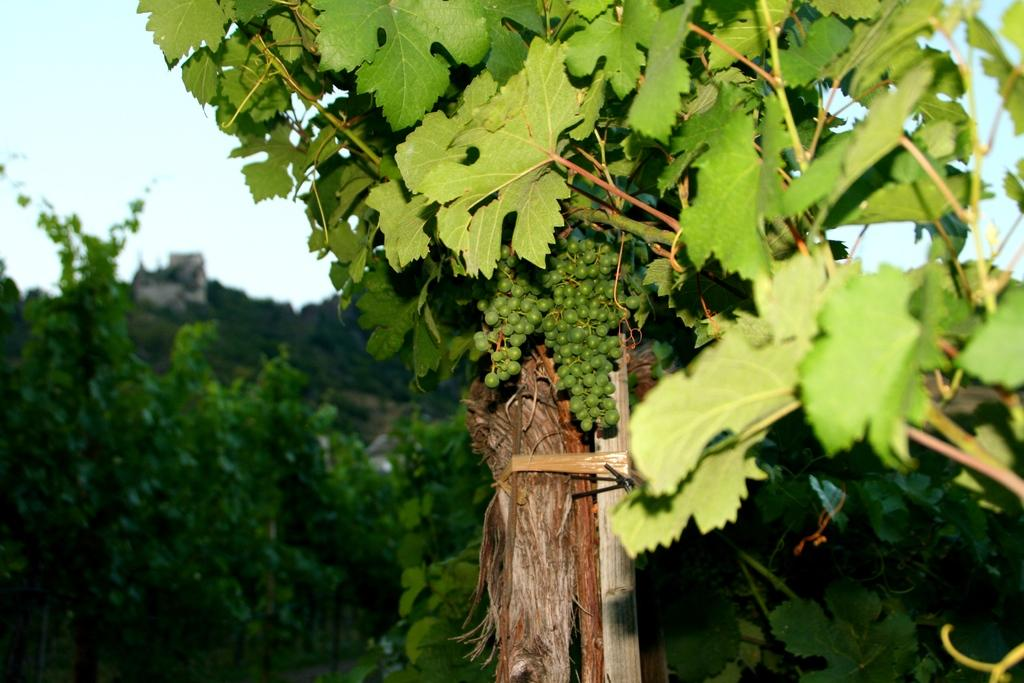What type of plants are in the image? There are grape plants in the image. What can be seen on the grape plants? There are grapes in the image. How would you describe the background of the image? The background of the image is slightly blurred. What else can be seen in the background besides the blurred area? There are additional plants visible in the background. What part of the natural environment is visible in the background? The sky is visible in the background. What type of jewel is being used to cut the grapes in the image? There is no jewel or cutting activity present in the image; it features grape plants with grapes on them. What experience can be gained from observing the grape plants in the image? The image does not convey any specific experience, but it may inspire a sense of appreciation for nature or agriculture. 